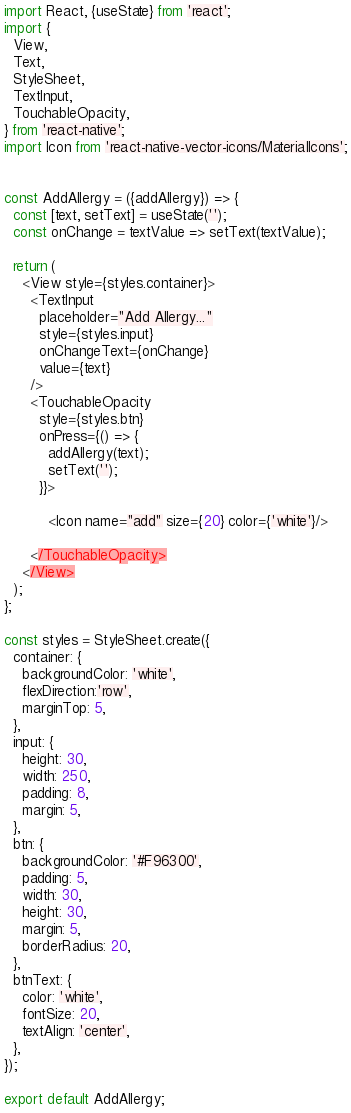<code> <loc_0><loc_0><loc_500><loc_500><_JavaScript_>import React, {useState} from 'react';
import {
  View,
  Text,
  StyleSheet,
  TextInput,
  TouchableOpacity,
} from 'react-native';
import Icon from 'react-native-vector-icons/MaterialIcons';


const AddAllergy = ({addAllergy}) => {
  const [text, setText] = useState('');
  const onChange = textValue => setText(textValue);

  return (
    <View style={styles.container}>
      <TextInput
        placeholder="Add Allergy..."
        style={styles.input}
        onChangeText={onChange}
        value={text}
      />
      <TouchableOpacity
        style={styles.btn}
        onPress={() => {
          addAllergy(text);
          setText('');
        }}>
        
          <Icon name="add" size={20} color={'white'}/> 
        
      </TouchableOpacity>
    </View>
  );
};

const styles = StyleSheet.create({
  container: {
    backgroundColor: 'white',
    flexDirection:'row',
    marginTop: 5,
  },
  input: {
    height: 30,
    width: 250,
    padding: 8,
    margin: 5,
  },
  btn: {
    backgroundColor: '#F96300',
    padding: 5,
    width: 30,
    height: 30,
    margin: 5,
    borderRadius: 20,
  },
  btnText: {
    color: 'white',
    fontSize: 20,
    textAlign: 'center',
  },
});

export default AddAllergy;</code> 